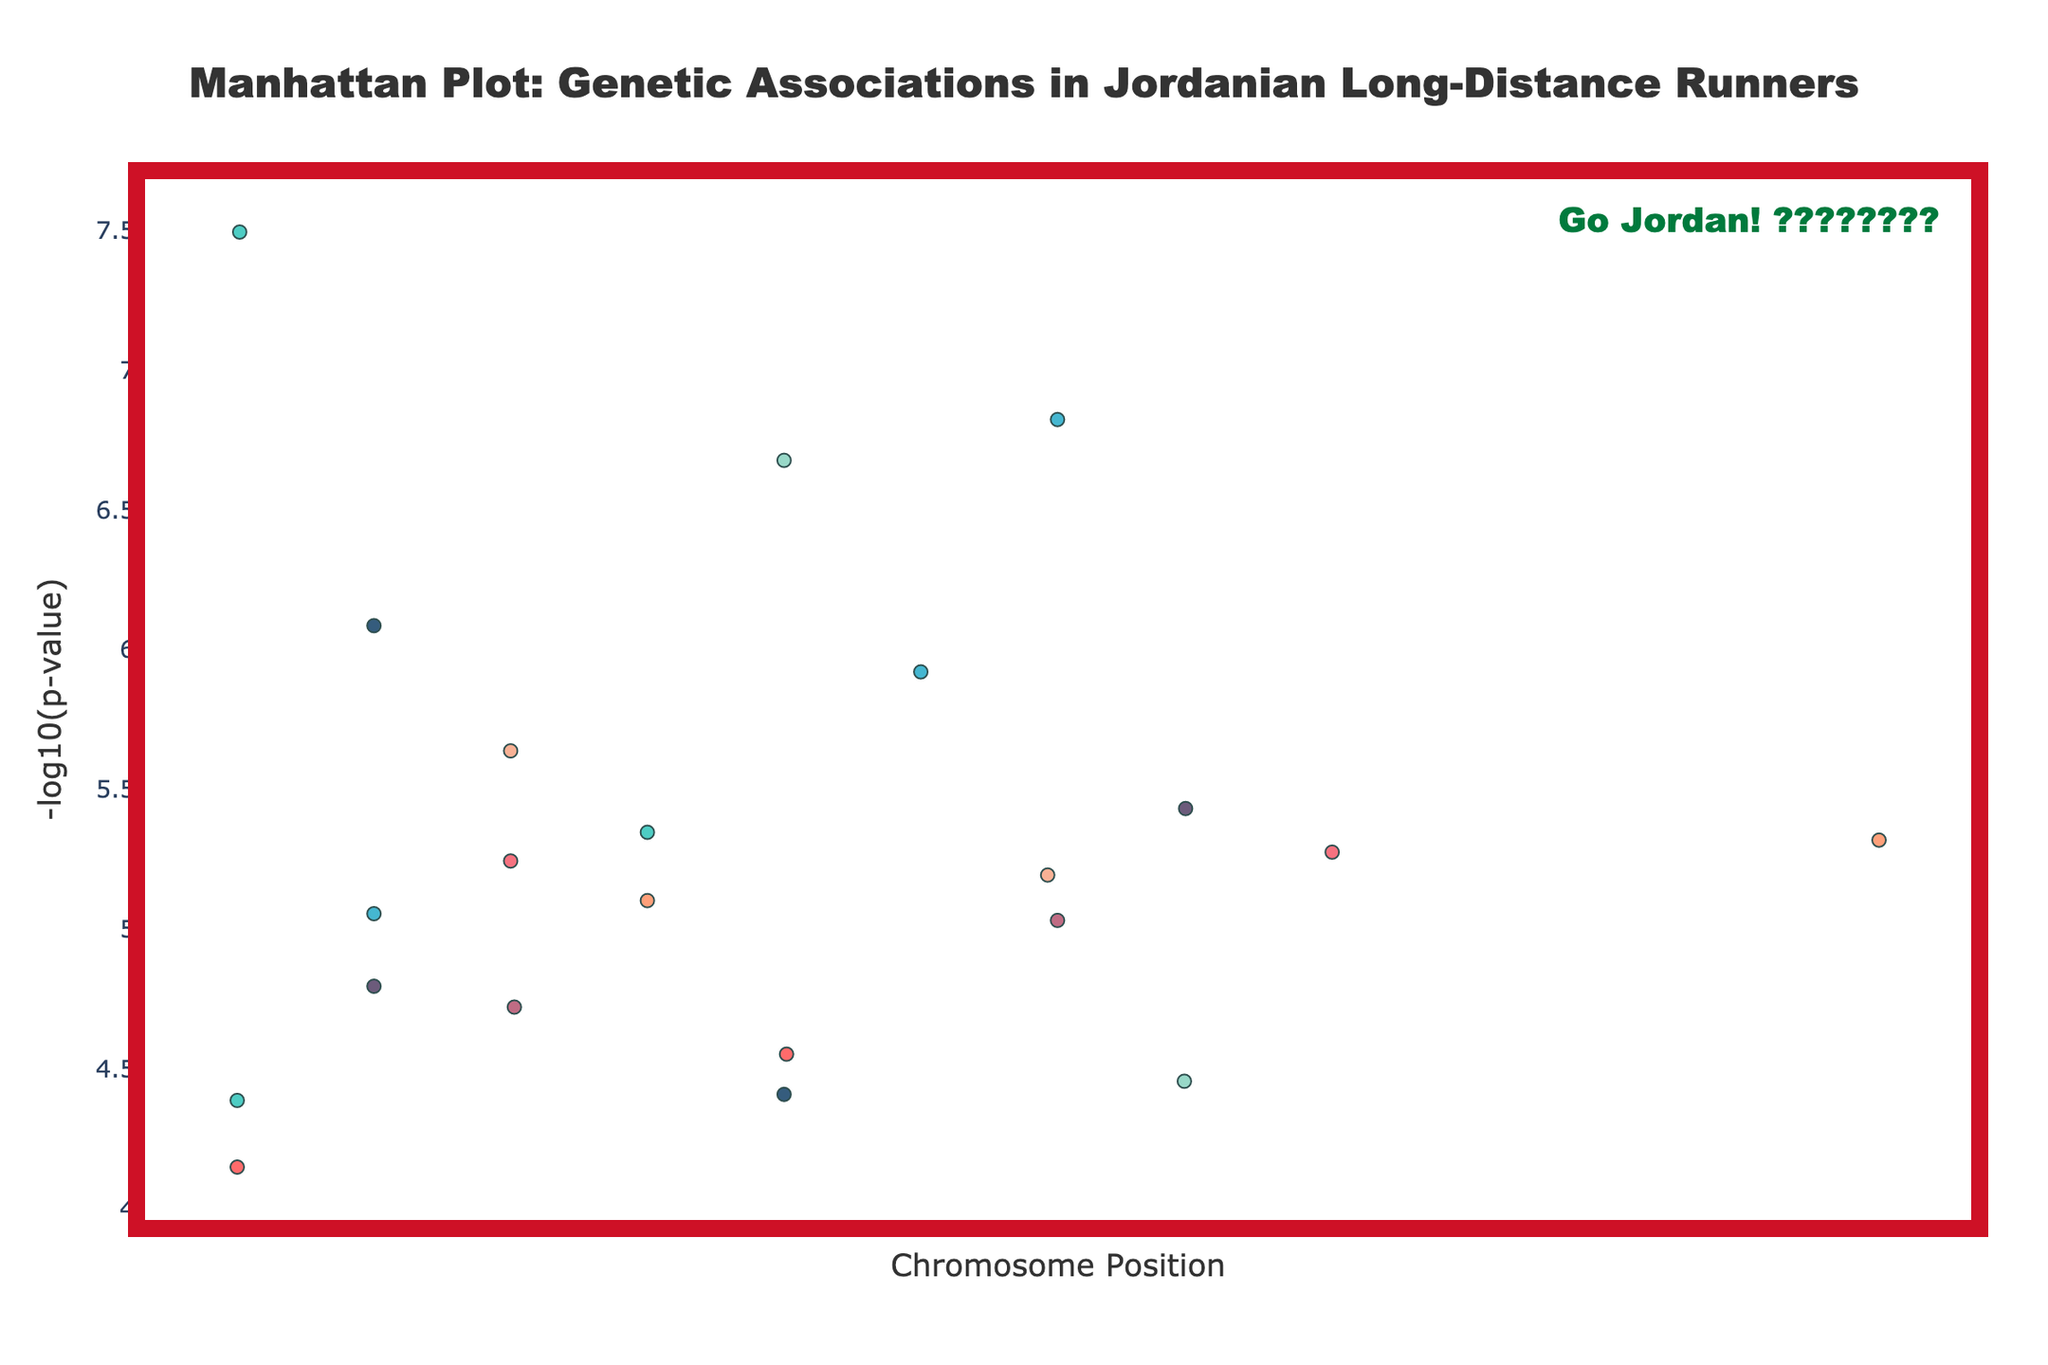What is the title of the plot? The title is usually displayed prominently at the top. In this case, it reads, "Manhattan Plot: Genetic Associations in Jordanian Long-Distance Runners."
Answer: Manhattan Plot: Genetic Associations in Jordanian Long-Distance Runners What is represented on the x-axis and y-axis? The x-axis represents Chromosome Position, and the y-axis represents -log10(p-value), as labeled on the plot.
Answer: Chromosome Position and -log10(p-value) Which gene has the most significant p-value? The most significant p-value will have the highest -log10(p-value). Looking at the plot, the gene ACTN3 on chromosome 1 has the highest peak, corresponding to a -log10(p-value) of 7.49.
Answer: ACTN3 How many genes are shown on Chromosome 2? We look at Chromosome 2 and identify the scatter points associated with it. There is only one point, corresponding to the gene ACE.
Answer: 1 What trait is associated with the gene found at position 56700000 on Chromosome 4? Find Chromosome 4, then locate the position 56700000. The gene at that location is EPAS1, and the associated trait listed is Hemoglobin concentration.
Answer: Hemoglobin concentration What is the range of -log10(p-value) in the plot? To find the range, identify the lowest and the highest points on the y-axis corresponding to -log10(p-value). The lowest value seen is around 3.15 (log10 of 7.1e-5) and the highest is about 7.49 (log10 of 3.2e-8).
Answer: Approximately 3.15 to 7.49 Which chromosomes have the genes related to mitochondrial function and mitochondrial biogenesis? Search for the genes NRF1 and TFAM, which correspond to mitochondrial function and mitochondrial biogenesis. From the plot, NRF1 is on Chromosome 5 and TFAM is on Chromosome 9.
Answer: Chromosomes 5 and 9 List all genes with -log10(p-value) greater than 5. Identify points with -log10(p-values) above 5 on the y-axis. The genes are ACTN3, ACE, and EPAS1.
Answer: ACTN3, ACE, and EPAS1 Which gene on Chromosome 8 has the highest -log10(p-value)? Look at Chromosome 8 and compare the heights of the points. HIF1A has the highest -log10(p-value).
Answer: HIF1A 